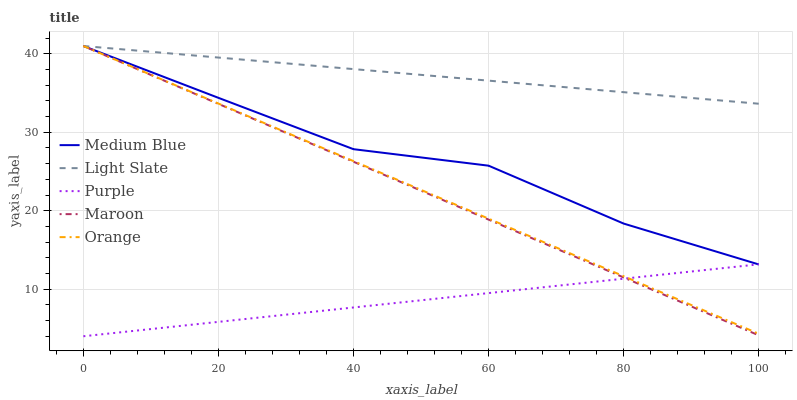Does Purple have the minimum area under the curve?
Answer yes or no. Yes. Does Light Slate have the maximum area under the curve?
Answer yes or no. Yes. Does Orange have the minimum area under the curve?
Answer yes or no. No. Does Orange have the maximum area under the curve?
Answer yes or no. No. Is Purple the smoothest?
Answer yes or no. Yes. Is Medium Blue the roughest?
Answer yes or no. Yes. Is Orange the smoothest?
Answer yes or no. No. Is Orange the roughest?
Answer yes or no. No. Does Orange have the lowest value?
Answer yes or no. No. Does Maroon have the highest value?
Answer yes or no. Yes. Does Purple have the highest value?
Answer yes or no. No. Is Purple less than Light Slate?
Answer yes or no. Yes. Is Light Slate greater than Purple?
Answer yes or no. Yes. Does Maroon intersect Purple?
Answer yes or no. Yes. Is Maroon less than Purple?
Answer yes or no. No. Is Maroon greater than Purple?
Answer yes or no. No. Does Purple intersect Light Slate?
Answer yes or no. No. 